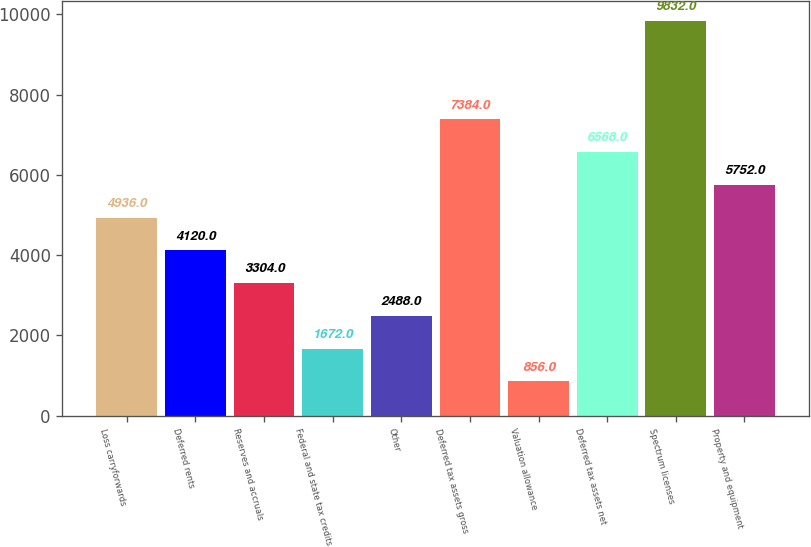Convert chart. <chart><loc_0><loc_0><loc_500><loc_500><bar_chart><fcel>Loss carryforwards<fcel>Deferred rents<fcel>Reserves and accruals<fcel>Federal and state tax credits<fcel>Other<fcel>Deferred tax assets gross<fcel>Valuation allowance<fcel>Deferred tax assets net<fcel>Spectrum licenses<fcel>Property and equipment<nl><fcel>4936<fcel>4120<fcel>3304<fcel>1672<fcel>2488<fcel>7384<fcel>856<fcel>6568<fcel>9832<fcel>5752<nl></chart> 